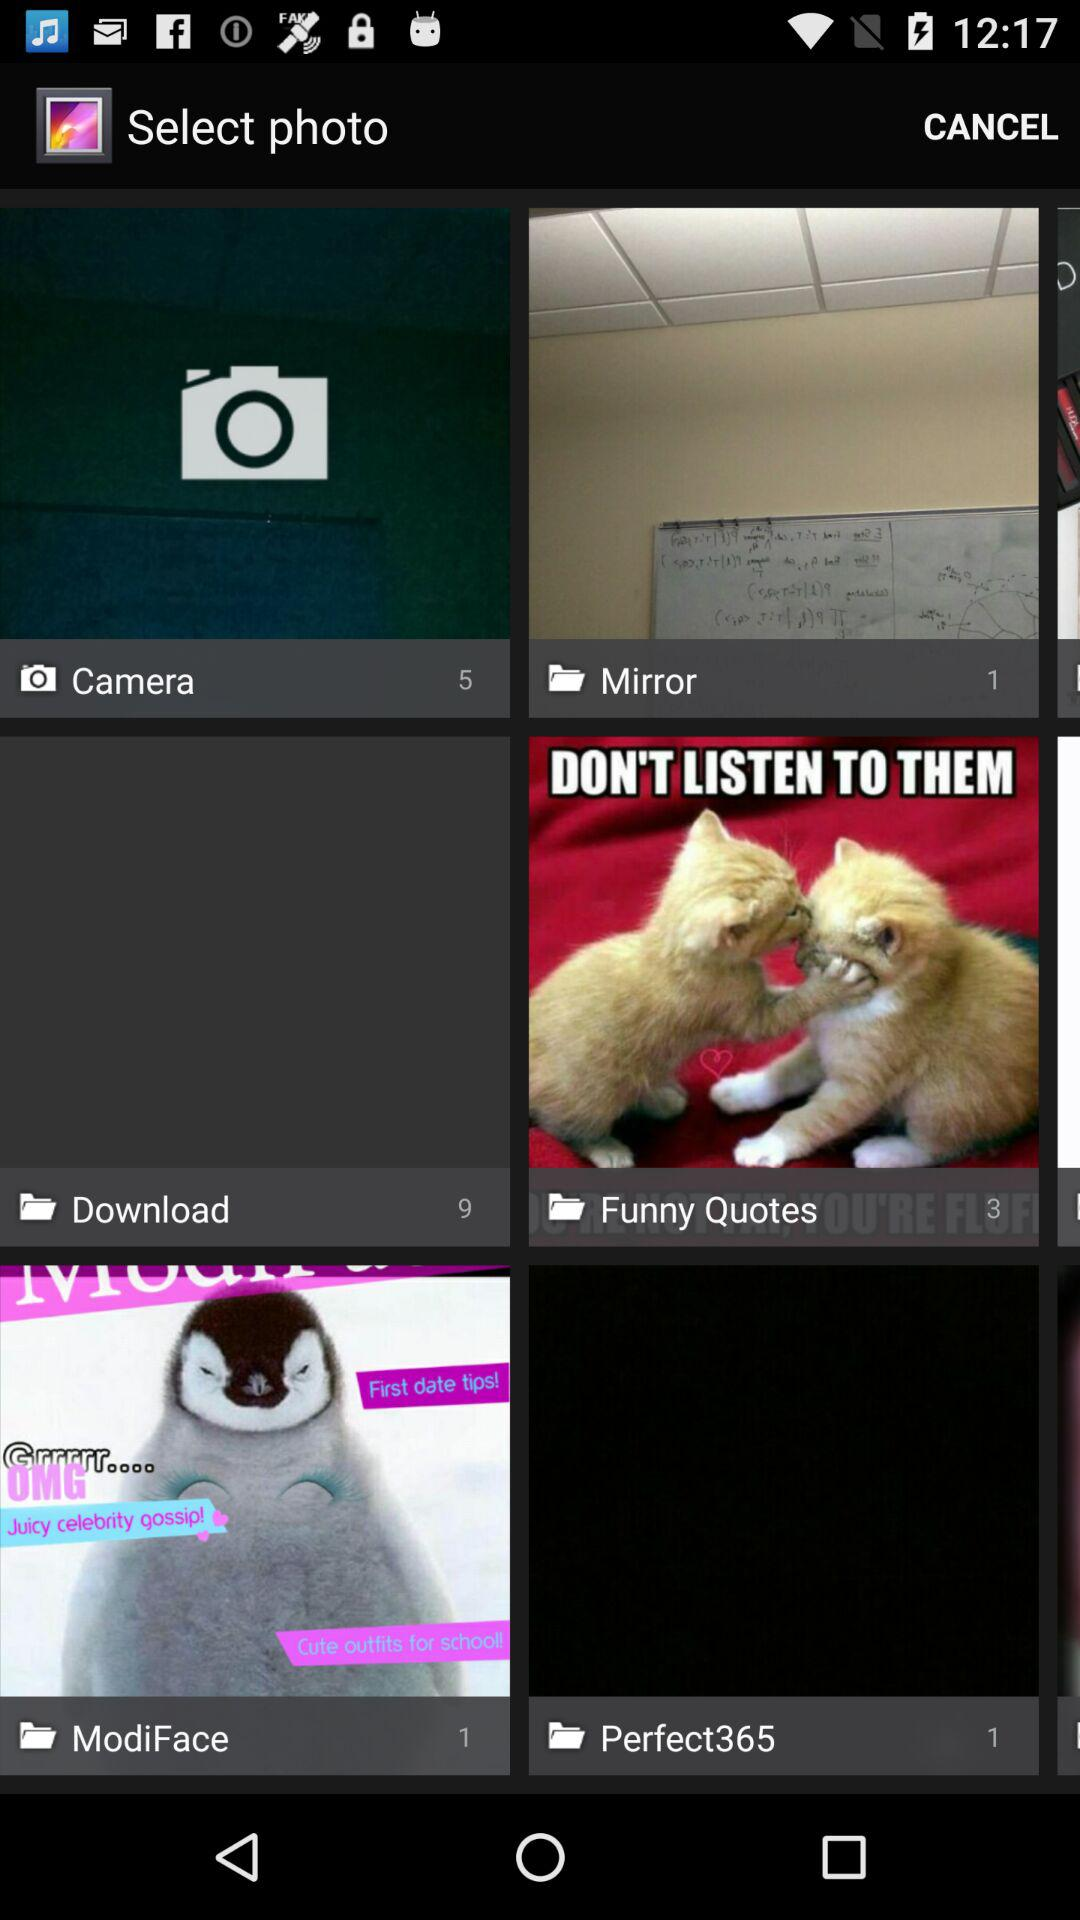Which folder has nine images? There are nine images in the "Download" folder. 